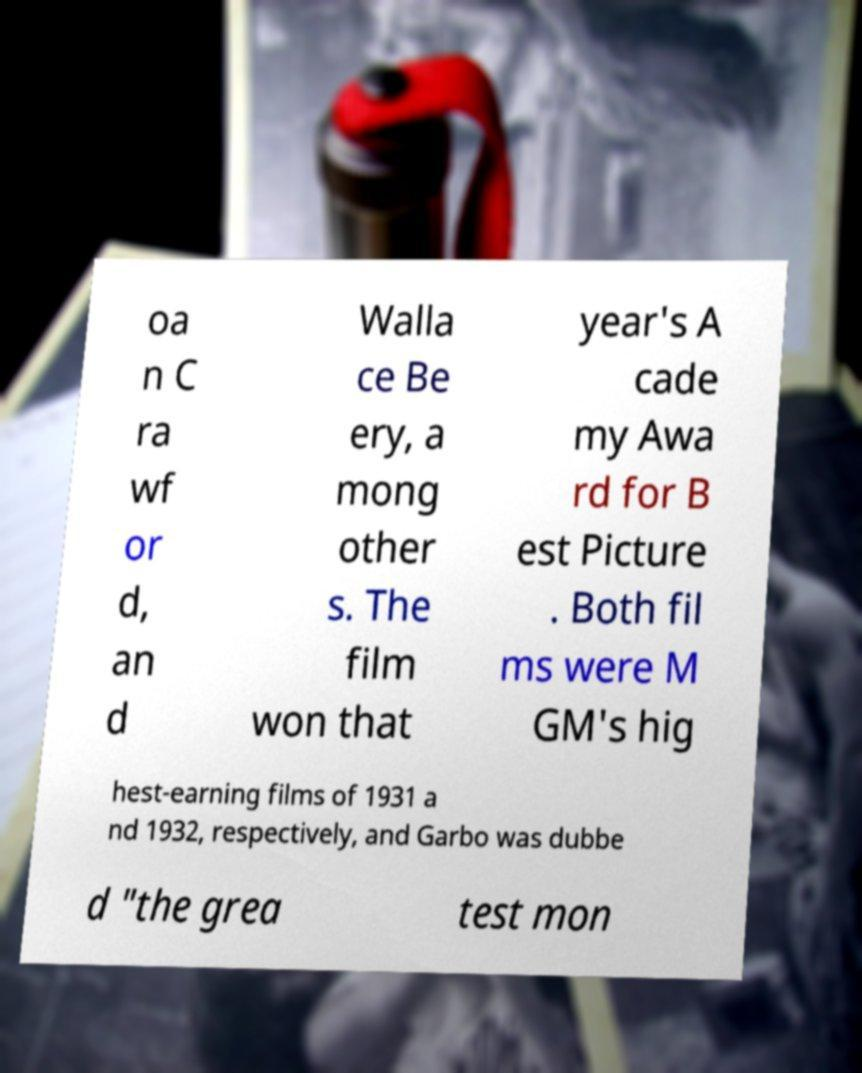What messages or text are displayed in this image? I need them in a readable, typed format. oa n C ra wf or d, an d Walla ce Be ery, a mong other s. The film won that year's A cade my Awa rd for B est Picture . Both fil ms were M GM's hig hest-earning films of 1931 a nd 1932, respectively, and Garbo was dubbe d "the grea test mon 